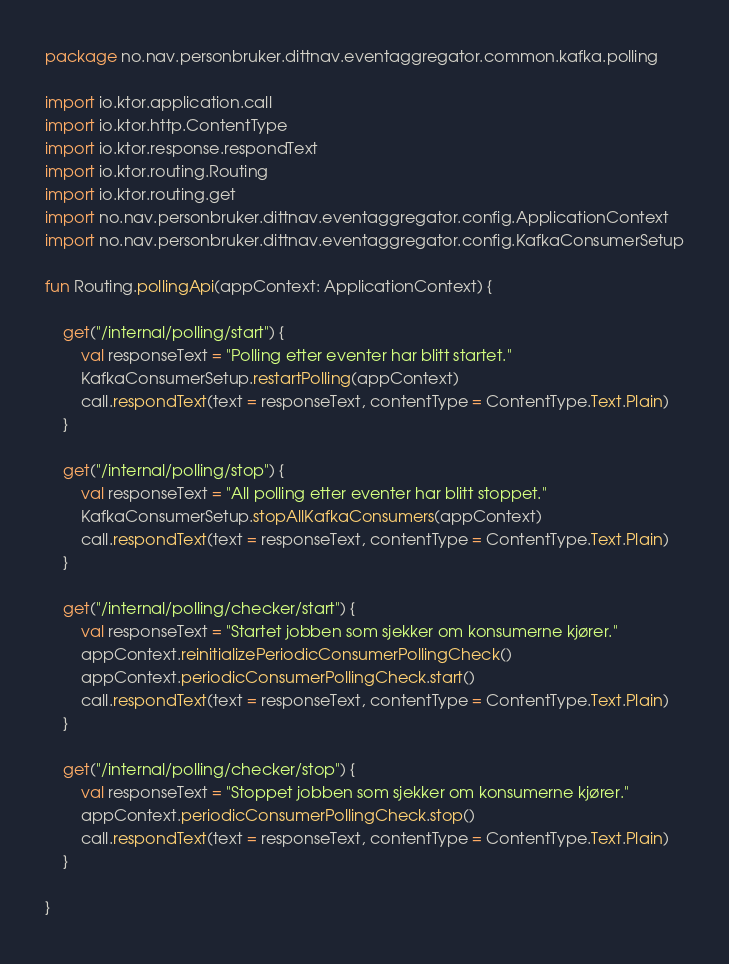<code> <loc_0><loc_0><loc_500><loc_500><_Kotlin_>package no.nav.personbruker.dittnav.eventaggregator.common.kafka.polling

import io.ktor.application.call
import io.ktor.http.ContentType
import io.ktor.response.respondText
import io.ktor.routing.Routing
import io.ktor.routing.get
import no.nav.personbruker.dittnav.eventaggregator.config.ApplicationContext
import no.nav.personbruker.dittnav.eventaggregator.config.KafkaConsumerSetup

fun Routing.pollingApi(appContext: ApplicationContext) {

    get("/internal/polling/start") {
        val responseText = "Polling etter eventer har blitt startet."
        KafkaConsumerSetup.restartPolling(appContext)
        call.respondText(text = responseText, contentType = ContentType.Text.Plain)
    }

    get("/internal/polling/stop") {
        val responseText = "All polling etter eventer har blitt stoppet."
        KafkaConsumerSetup.stopAllKafkaConsumers(appContext)
        call.respondText(text = responseText, contentType = ContentType.Text.Plain)
    }

    get("/internal/polling/checker/start") {
        val responseText = "Startet jobben som sjekker om konsumerne kjører."
        appContext.reinitializePeriodicConsumerPollingCheck()
        appContext.periodicConsumerPollingCheck.start()
        call.respondText(text = responseText, contentType = ContentType.Text.Plain)
    }

    get("/internal/polling/checker/stop") {
        val responseText = "Stoppet jobben som sjekker om konsumerne kjører."
        appContext.periodicConsumerPollingCheck.stop()
        call.respondText(text = responseText, contentType = ContentType.Text.Plain)
    }

}
</code> 